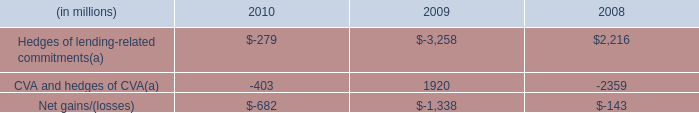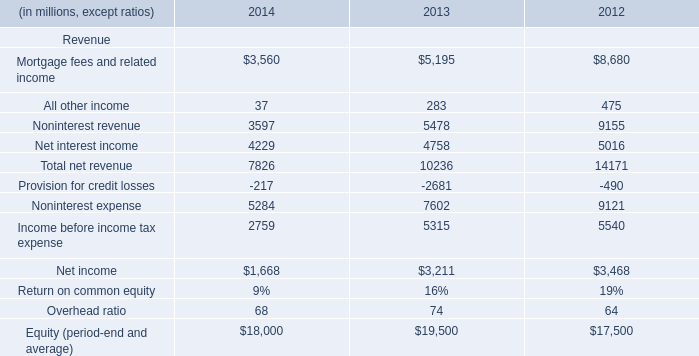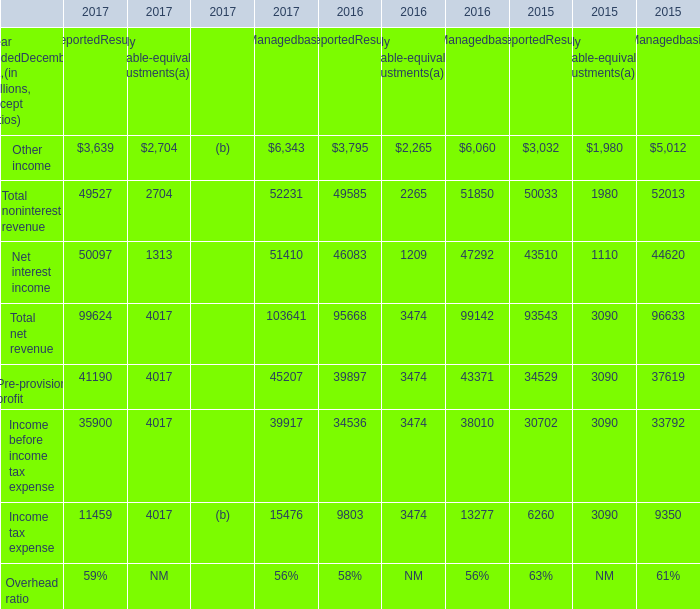Which section is Other income the highest in 2017? 
Answer: Managedbasis. 